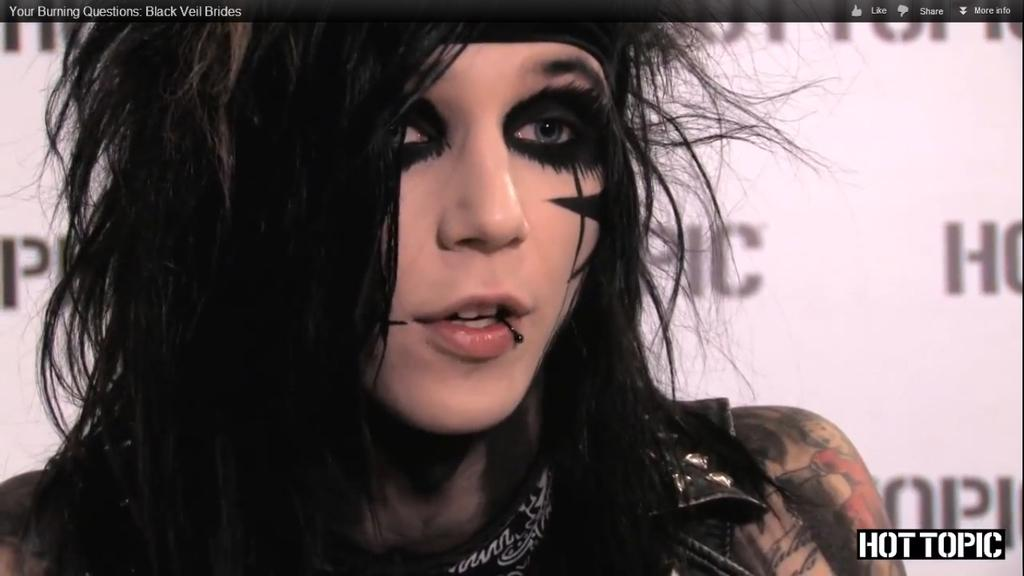Who is present in the image? There is a lady in the image. What can be seen in the background of the image? There is a banner with text in the background of the image. What is located at the bottom of the image? There is a logo at the bottom of the image. What type of van is parked next to the lady in the image? There is no van present in the image; it only features a lady, a banner with text, and a logo. What appliance is the lady using in the image? There is no appliance visible in the image, as it only features a lady, a banner with text, and a logo. 